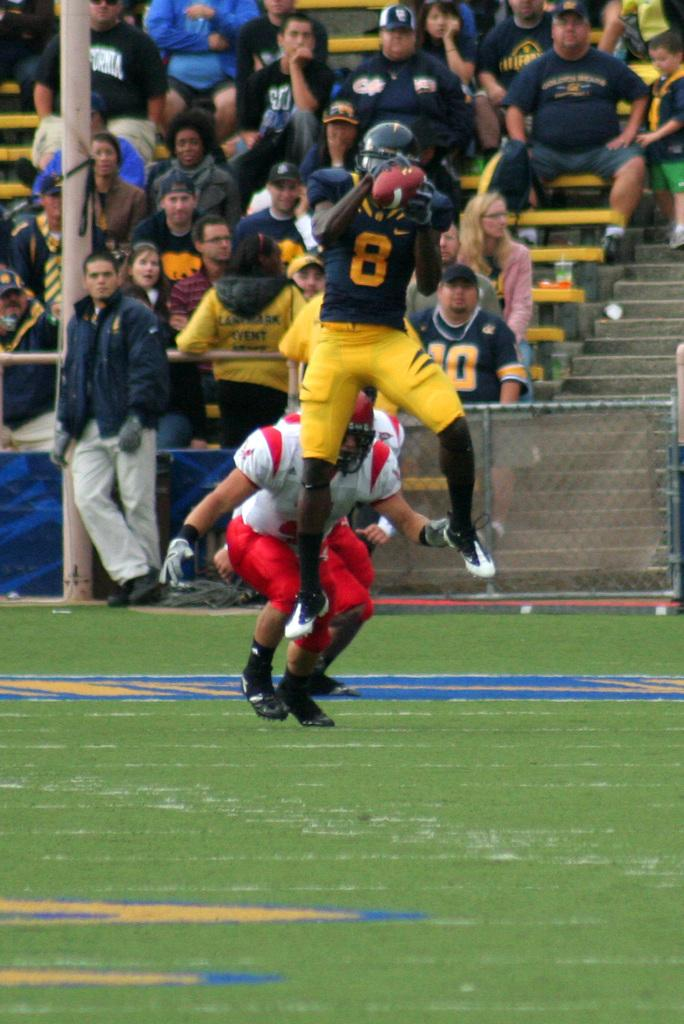What are the people in the image doing? The players are playing in a playground. Where are the people sitting and standing in the image? They are on the stairs of a stadium. What object can be seen in the image that is not related to the playground or stadium? There is a pole in the image. What type of thumb can be seen holding a heart in the image? There is no thumb or heart present in the image. What kind of journey is depicted in the image? The image does not depict a journey; it shows people playing in a playground and sitting on stadium stairs. 